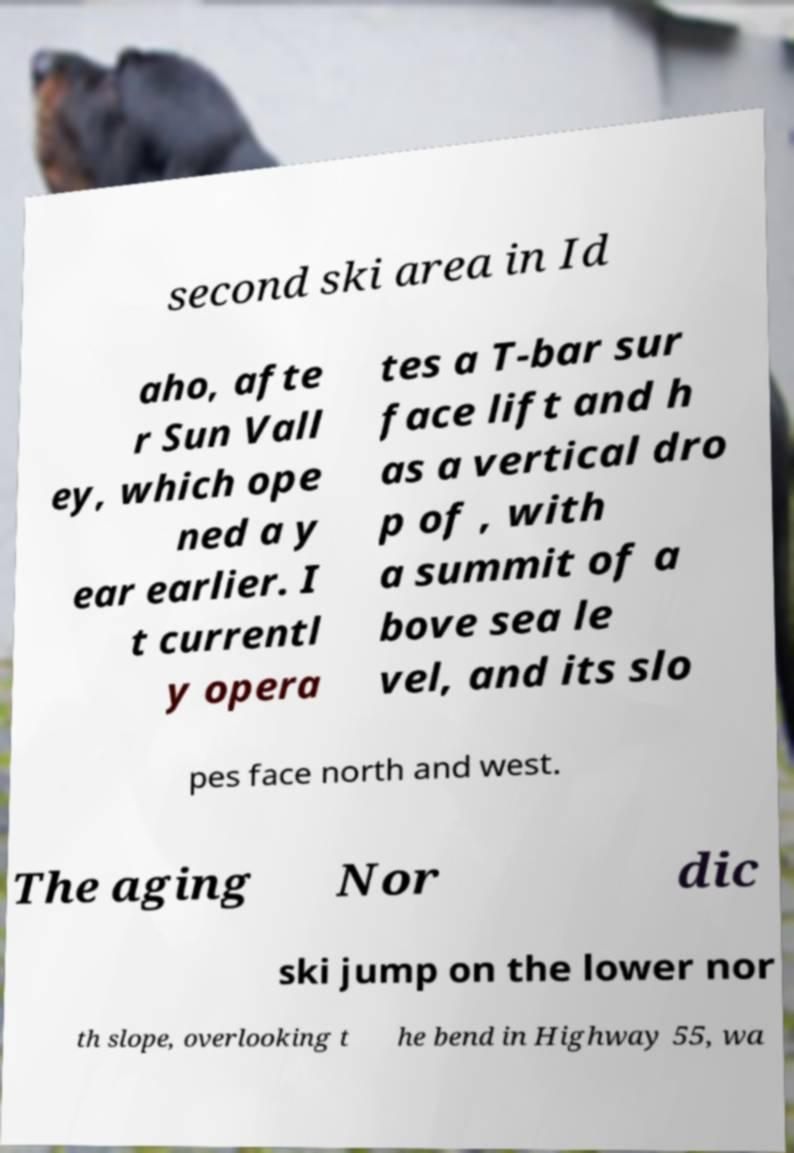Please read and relay the text visible in this image. What does it say? second ski area in Id aho, afte r Sun Vall ey, which ope ned a y ear earlier. I t currentl y opera tes a T-bar sur face lift and h as a vertical dro p of , with a summit of a bove sea le vel, and its slo pes face north and west. The aging Nor dic ski jump on the lower nor th slope, overlooking t he bend in Highway 55, wa 